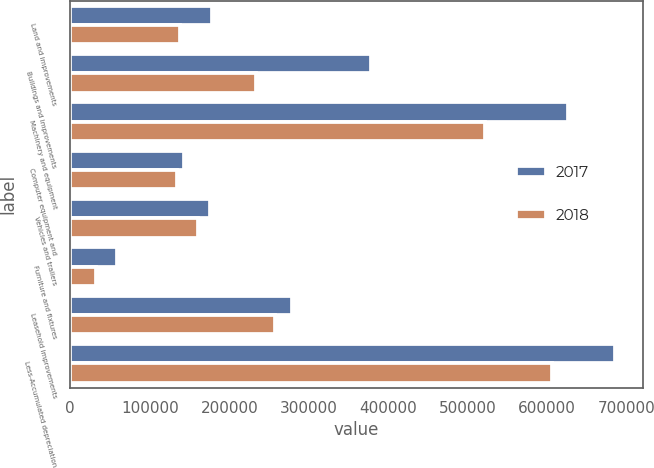Convert chart to OTSL. <chart><loc_0><loc_0><loc_500><loc_500><stacked_bar_chart><ecel><fcel>Land and improvements<fcel>Buildings and improvements<fcel>Machinery and equipment<fcel>Computer equipment and<fcel>Vehicles and trailers<fcel>Furniture and fixtures<fcel>Leasehold improvements<fcel>Less-Accumulated depreciation<nl><fcel>2017<fcel>177998<fcel>378490<fcel>626615<fcel>143547<fcel>176186<fcel>58919<fcel>278687<fcel>685751<nl><fcel>2018<fcel>137790<fcel>233078<fcel>521526<fcel>133753<fcel>161269<fcel>31794<fcel>257506<fcel>606112<nl></chart> 